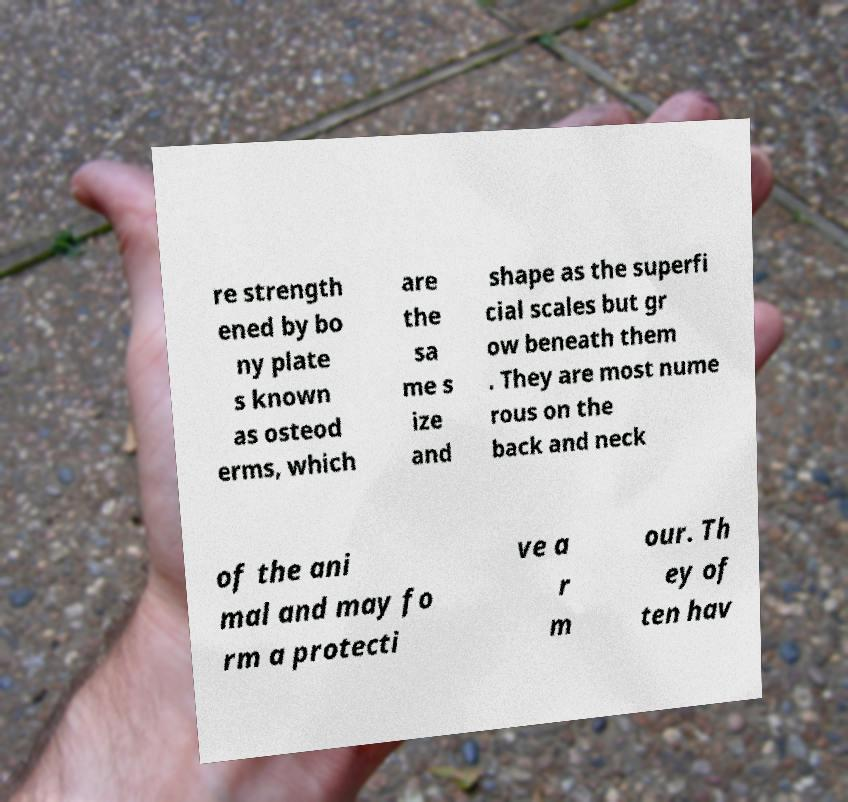Can you read and provide the text displayed in the image?This photo seems to have some interesting text. Can you extract and type it out for me? re strength ened by bo ny plate s known as osteod erms, which are the sa me s ize and shape as the superfi cial scales but gr ow beneath them . They are most nume rous on the back and neck of the ani mal and may fo rm a protecti ve a r m our. Th ey of ten hav 